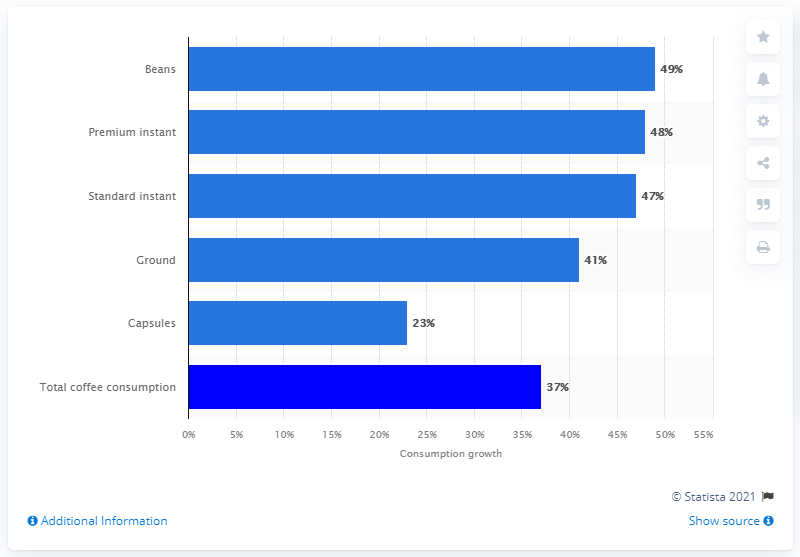Indicate a few pertinent items in this graphic. Home consumption of coffee beans in Australia during the COVID-19 outbreak increased by 49%. 